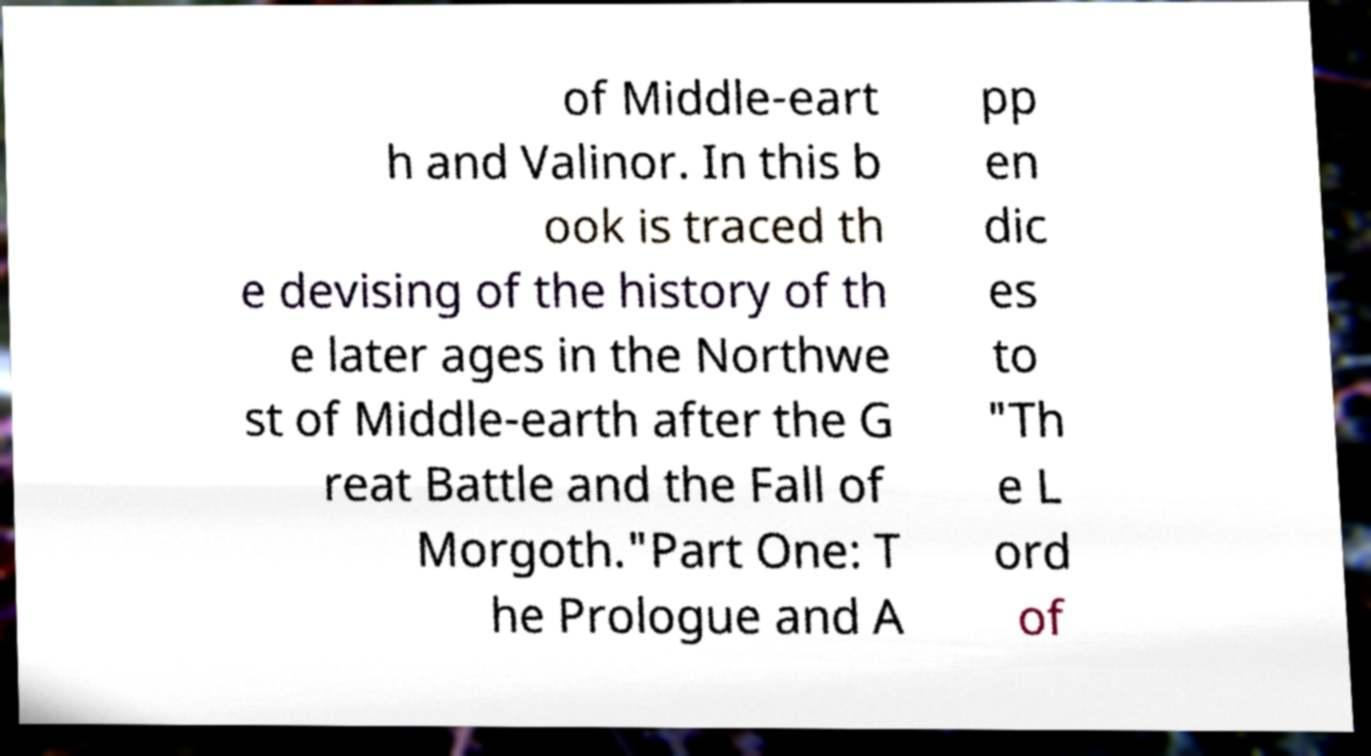I need the written content from this picture converted into text. Can you do that? of Middle-eart h and Valinor. In this b ook is traced th e devising of the history of th e later ages in the Northwe st of Middle-earth after the G reat Battle and the Fall of Morgoth."Part One: T he Prologue and A pp en dic es to "Th e L ord of 